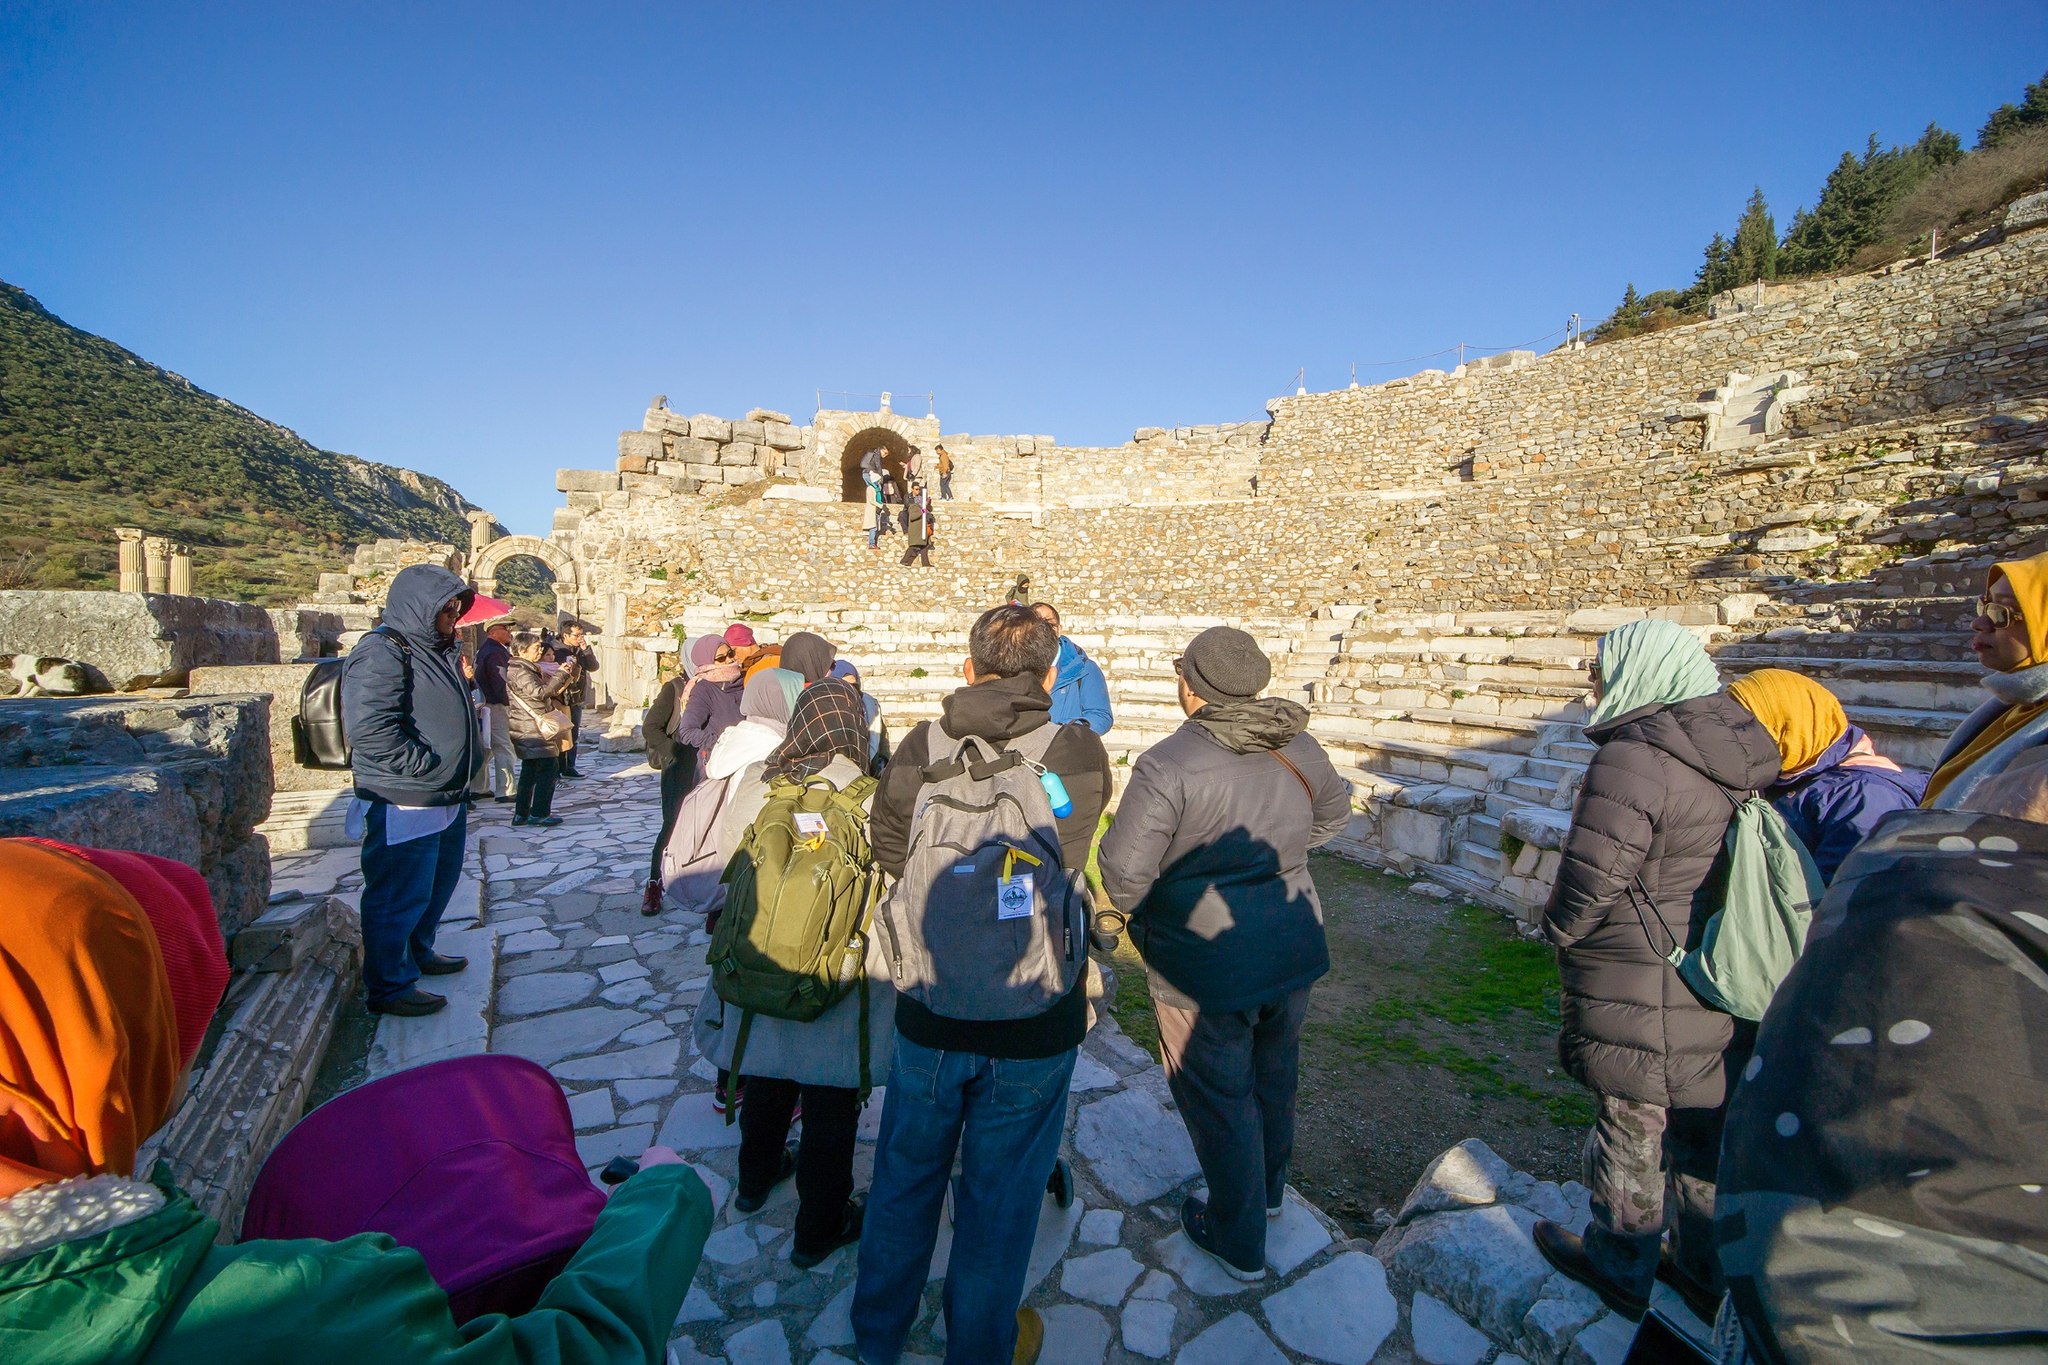What do you think is going on in this snapshot? In the image, a group of tourists are venturing through an ancient archaeological site, possibly a historic ruin, on a bright and sunny day. They appear to be attentively exploring and learning about the site’s historical significance, as they follow a guide or examine the stone structures around them. The pathway they are standing on is made of weathered stone, which seems to have witnessed centuries of history. The stone wall in the background, with its archway, serves as a notable focal point, attracting the curious gazes of the tourists. The surrounding nature, consisting of scattered trees and a mountainous backdrop, adds a serene and picturesque quality to this scene of exploration and discovery. The tourists, wrapped in jackets and hats to shield themselves from the weather, demonstrate a keen interest, ready to uncover the mysteries this ancient place holds. 